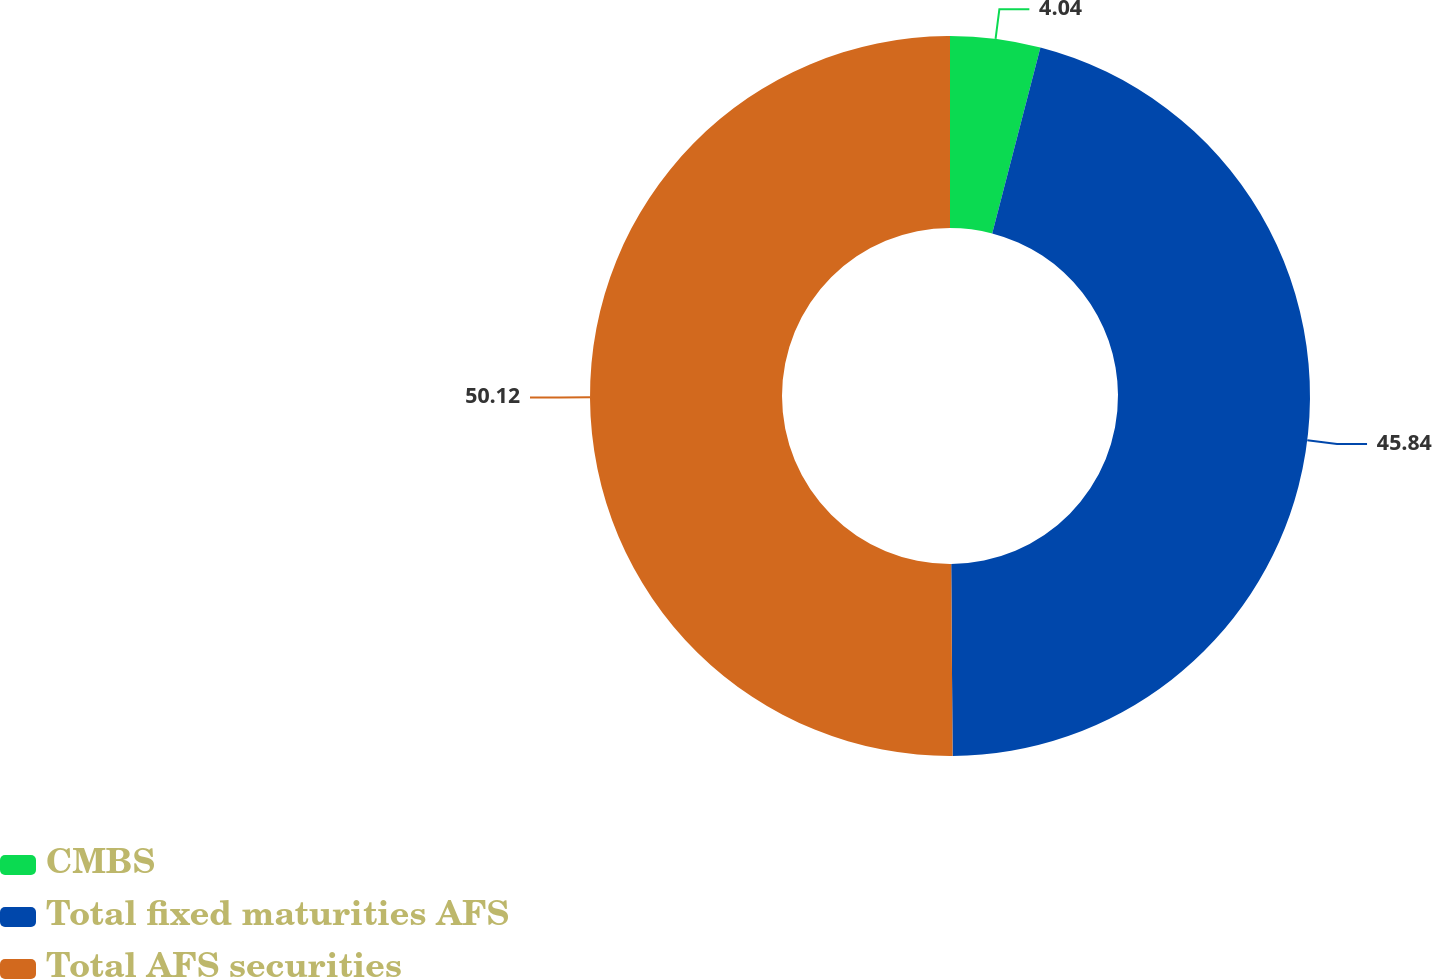Convert chart to OTSL. <chart><loc_0><loc_0><loc_500><loc_500><pie_chart><fcel>CMBS<fcel>Total fixed maturities AFS<fcel>Total AFS securities<nl><fcel>4.04%<fcel>45.84%<fcel>50.11%<nl></chart> 